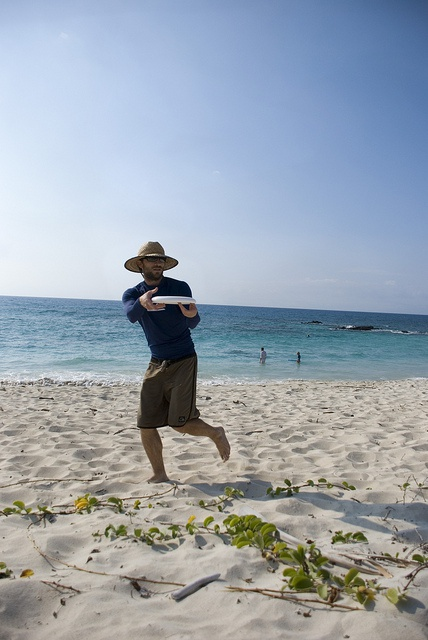Describe the objects in this image and their specific colors. I can see people in darkgray, black, and maroon tones, frisbee in darkgray, lavender, and gray tones, people in darkgray, gray, and black tones, and people in darkgray, black, gray, and navy tones in this image. 